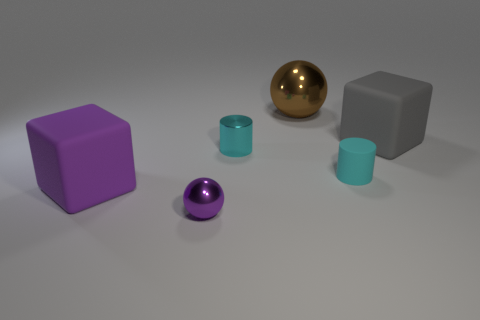Add 4 purple metallic spheres. How many objects exist? 10 Subtract all blocks. How many objects are left? 4 Add 2 purple metal things. How many purple metal things exist? 3 Subtract 0 yellow spheres. How many objects are left? 6 Subtract all gray cubes. Subtract all tiny green rubber balls. How many objects are left? 5 Add 6 big brown balls. How many big brown balls are left? 7 